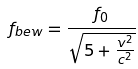<formula> <loc_0><loc_0><loc_500><loc_500>f _ { b e w } = \frac { f _ { 0 } } { \sqrt { 5 + \frac { v ^ { 2 } } { c ^ { 2 } } } }</formula> 